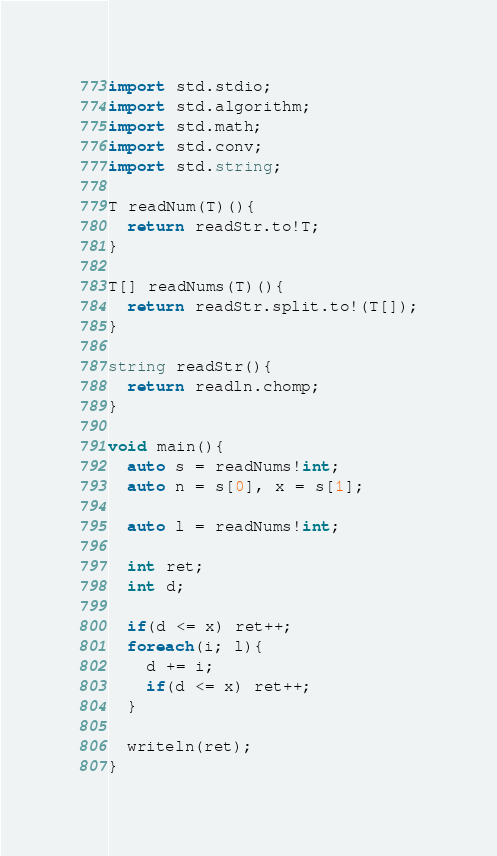Convert code to text. <code><loc_0><loc_0><loc_500><loc_500><_D_>import std.stdio;
import std.algorithm;
import std.math;
import std.conv;
import std.string;

T readNum(T)(){
  return readStr.to!T;
}

T[] readNums(T)(){
  return readStr.split.to!(T[]);
}

string readStr(){
  return readln.chomp;
}

void main(){
  auto s = readNums!int;
  auto n = s[0], x = s[1];

  auto l = readNums!int;

  int ret;
  int d;

  if(d <= x) ret++;
  foreach(i; l){
    d += i;
    if(d <= x) ret++;
  }

  writeln(ret);
}
</code> 